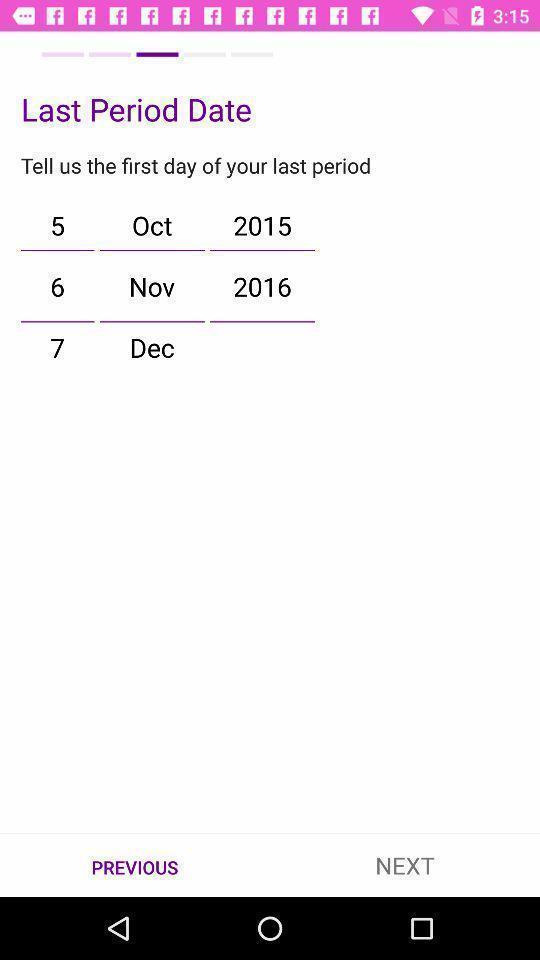Give me a narrative description of this picture. Period date update page in a menstrual cycle tracker app. 